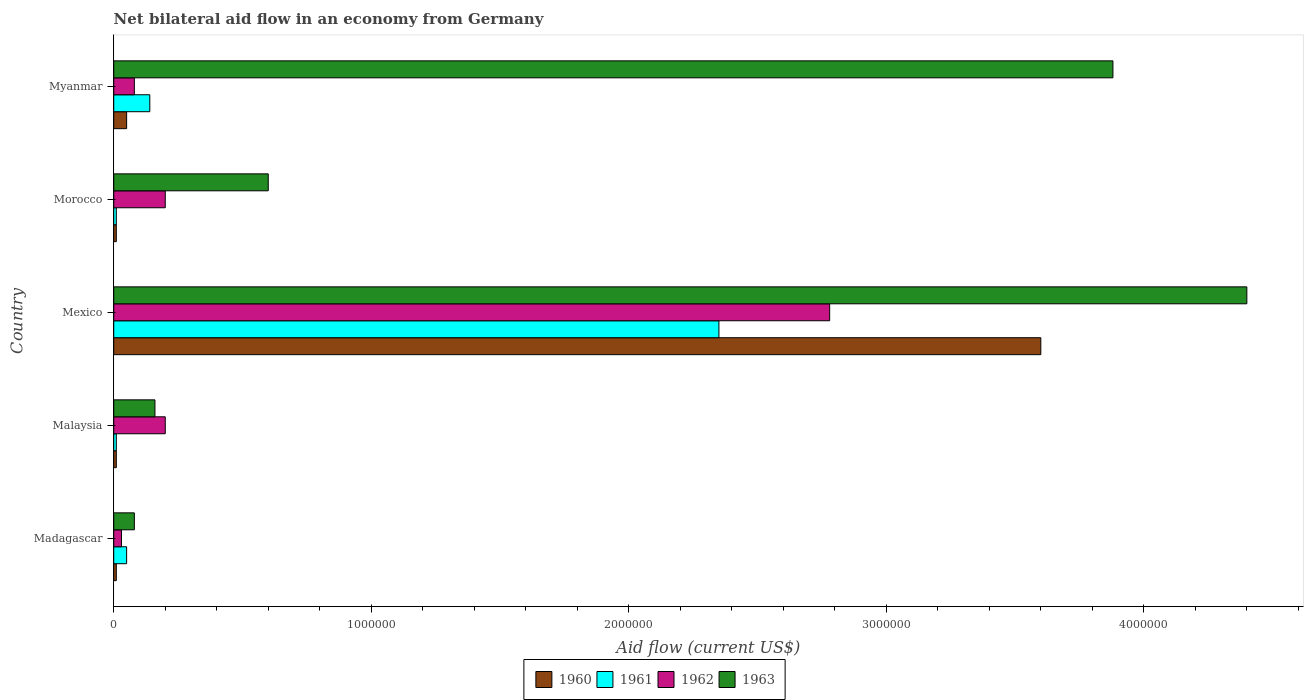How many different coloured bars are there?
Offer a very short reply. 4. Are the number of bars on each tick of the Y-axis equal?
Offer a terse response. Yes. What is the label of the 3rd group of bars from the top?
Your answer should be very brief. Mexico. What is the net bilateral aid flow in 1963 in Malaysia?
Ensure brevity in your answer.  1.60e+05. Across all countries, what is the maximum net bilateral aid flow in 1962?
Your response must be concise. 2.78e+06. Across all countries, what is the minimum net bilateral aid flow in 1962?
Give a very brief answer. 3.00e+04. In which country was the net bilateral aid flow in 1963 minimum?
Keep it short and to the point. Madagascar. What is the total net bilateral aid flow in 1963 in the graph?
Provide a short and direct response. 9.12e+06. What is the difference between the net bilateral aid flow in 1963 in Malaysia and that in Mexico?
Your response must be concise. -4.24e+06. What is the difference between the net bilateral aid flow in 1963 in Morocco and the net bilateral aid flow in 1962 in Mexico?
Keep it short and to the point. -2.18e+06. What is the average net bilateral aid flow in 1961 per country?
Your response must be concise. 5.12e+05. What is the difference between the highest and the second highest net bilateral aid flow in 1961?
Give a very brief answer. 2.21e+06. What is the difference between the highest and the lowest net bilateral aid flow in 1963?
Your answer should be very brief. 4.32e+06. What does the 3rd bar from the top in Malaysia represents?
Offer a very short reply. 1961. What does the 2nd bar from the bottom in Madagascar represents?
Offer a terse response. 1961. How many bars are there?
Offer a very short reply. 20. Are all the bars in the graph horizontal?
Offer a very short reply. Yes. Are the values on the major ticks of X-axis written in scientific E-notation?
Keep it short and to the point. No. Does the graph contain any zero values?
Provide a short and direct response. No. Does the graph contain grids?
Your answer should be compact. No. Where does the legend appear in the graph?
Ensure brevity in your answer.  Bottom center. How many legend labels are there?
Offer a very short reply. 4. How are the legend labels stacked?
Offer a terse response. Horizontal. What is the title of the graph?
Offer a terse response. Net bilateral aid flow in an economy from Germany. Does "2005" appear as one of the legend labels in the graph?
Provide a short and direct response. No. What is the label or title of the X-axis?
Offer a terse response. Aid flow (current US$). What is the label or title of the Y-axis?
Your response must be concise. Country. What is the Aid flow (current US$) in 1961 in Madagascar?
Your response must be concise. 5.00e+04. What is the Aid flow (current US$) in 1962 in Madagascar?
Your answer should be compact. 3.00e+04. What is the Aid flow (current US$) of 1961 in Malaysia?
Offer a terse response. 10000. What is the Aid flow (current US$) in 1960 in Mexico?
Provide a succinct answer. 3.60e+06. What is the Aid flow (current US$) of 1961 in Mexico?
Your response must be concise. 2.35e+06. What is the Aid flow (current US$) of 1962 in Mexico?
Give a very brief answer. 2.78e+06. What is the Aid flow (current US$) of 1963 in Mexico?
Keep it short and to the point. 4.40e+06. What is the Aid flow (current US$) in 1960 in Morocco?
Give a very brief answer. 10000. What is the Aid flow (current US$) in 1963 in Morocco?
Provide a succinct answer. 6.00e+05. What is the Aid flow (current US$) in 1960 in Myanmar?
Offer a terse response. 5.00e+04. What is the Aid flow (current US$) in 1962 in Myanmar?
Your answer should be compact. 8.00e+04. What is the Aid flow (current US$) of 1963 in Myanmar?
Provide a short and direct response. 3.88e+06. Across all countries, what is the maximum Aid flow (current US$) in 1960?
Give a very brief answer. 3.60e+06. Across all countries, what is the maximum Aid flow (current US$) of 1961?
Offer a terse response. 2.35e+06. Across all countries, what is the maximum Aid flow (current US$) of 1962?
Offer a very short reply. 2.78e+06. Across all countries, what is the maximum Aid flow (current US$) in 1963?
Your answer should be very brief. 4.40e+06. Across all countries, what is the minimum Aid flow (current US$) in 1960?
Your answer should be very brief. 10000. What is the total Aid flow (current US$) of 1960 in the graph?
Provide a short and direct response. 3.68e+06. What is the total Aid flow (current US$) in 1961 in the graph?
Provide a short and direct response. 2.56e+06. What is the total Aid flow (current US$) of 1962 in the graph?
Offer a very short reply. 3.29e+06. What is the total Aid flow (current US$) of 1963 in the graph?
Give a very brief answer. 9.12e+06. What is the difference between the Aid flow (current US$) in 1960 in Madagascar and that in Mexico?
Provide a succinct answer. -3.59e+06. What is the difference between the Aid flow (current US$) in 1961 in Madagascar and that in Mexico?
Keep it short and to the point. -2.30e+06. What is the difference between the Aid flow (current US$) of 1962 in Madagascar and that in Mexico?
Your answer should be very brief. -2.75e+06. What is the difference between the Aid flow (current US$) in 1963 in Madagascar and that in Mexico?
Offer a very short reply. -4.32e+06. What is the difference between the Aid flow (current US$) in 1961 in Madagascar and that in Morocco?
Make the answer very short. 4.00e+04. What is the difference between the Aid flow (current US$) in 1962 in Madagascar and that in Morocco?
Your response must be concise. -1.70e+05. What is the difference between the Aid flow (current US$) in 1963 in Madagascar and that in Morocco?
Ensure brevity in your answer.  -5.20e+05. What is the difference between the Aid flow (current US$) of 1963 in Madagascar and that in Myanmar?
Ensure brevity in your answer.  -3.80e+06. What is the difference between the Aid flow (current US$) in 1960 in Malaysia and that in Mexico?
Your response must be concise. -3.59e+06. What is the difference between the Aid flow (current US$) of 1961 in Malaysia and that in Mexico?
Offer a terse response. -2.34e+06. What is the difference between the Aid flow (current US$) of 1962 in Malaysia and that in Mexico?
Your response must be concise. -2.58e+06. What is the difference between the Aid flow (current US$) in 1963 in Malaysia and that in Mexico?
Your answer should be very brief. -4.24e+06. What is the difference between the Aid flow (current US$) of 1960 in Malaysia and that in Morocco?
Your answer should be compact. 0. What is the difference between the Aid flow (current US$) in 1961 in Malaysia and that in Morocco?
Your answer should be very brief. 0. What is the difference between the Aid flow (current US$) in 1962 in Malaysia and that in Morocco?
Provide a short and direct response. 0. What is the difference between the Aid flow (current US$) of 1963 in Malaysia and that in Morocco?
Your response must be concise. -4.40e+05. What is the difference between the Aid flow (current US$) of 1963 in Malaysia and that in Myanmar?
Offer a very short reply. -3.72e+06. What is the difference between the Aid flow (current US$) of 1960 in Mexico and that in Morocco?
Provide a short and direct response. 3.59e+06. What is the difference between the Aid flow (current US$) in 1961 in Mexico and that in Morocco?
Offer a terse response. 2.34e+06. What is the difference between the Aid flow (current US$) of 1962 in Mexico and that in Morocco?
Give a very brief answer. 2.58e+06. What is the difference between the Aid flow (current US$) in 1963 in Mexico and that in Morocco?
Your answer should be very brief. 3.80e+06. What is the difference between the Aid flow (current US$) in 1960 in Mexico and that in Myanmar?
Provide a short and direct response. 3.55e+06. What is the difference between the Aid flow (current US$) of 1961 in Mexico and that in Myanmar?
Give a very brief answer. 2.21e+06. What is the difference between the Aid flow (current US$) of 1962 in Mexico and that in Myanmar?
Keep it short and to the point. 2.70e+06. What is the difference between the Aid flow (current US$) in 1963 in Mexico and that in Myanmar?
Keep it short and to the point. 5.20e+05. What is the difference between the Aid flow (current US$) of 1961 in Morocco and that in Myanmar?
Your response must be concise. -1.30e+05. What is the difference between the Aid flow (current US$) of 1963 in Morocco and that in Myanmar?
Give a very brief answer. -3.28e+06. What is the difference between the Aid flow (current US$) in 1960 in Madagascar and the Aid flow (current US$) in 1963 in Malaysia?
Offer a terse response. -1.50e+05. What is the difference between the Aid flow (current US$) in 1961 in Madagascar and the Aid flow (current US$) in 1962 in Malaysia?
Ensure brevity in your answer.  -1.50e+05. What is the difference between the Aid flow (current US$) of 1960 in Madagascar and the Aid flow (current US$) of 1961 in Mexico?
Keep it short and to the point. -2.34e+06. What is the difference between the Aid flow (current US$) of 1960 in Madagascar and the Aid flow (current US$) of 1962 in Mexico?
Provide a short and direct response. -2.77e+06. What is the difference between the Aid flow (current US$) in 1960 in Madagascar and the Aid flow (current US$) in 1963 in Mexico?
Offer a terse response. -4.39e+06. What is the difference between the Aid flow (current US$) of 1961 in Madagascar and the Aid flow (current US$) of 1962 in Mexico?
Keep it short and to the point. -2.73e+06. What is the difference between the Aid flow (current US$) of 1961 in Madagascar and the Aid flow (current US$) of 1963 in Mexico?
Make the answer very short. -4.35e+06. What is the difference between the Aid flow (current US$) of 1962 in Madagascar and the Aid flow (current US$) of 1963 in Mexico?
Your answer should be compact. -4.37e+06. What is the difference between the Aid flow (current US$) of 1960 in Madagascar and the Aid flow (current US$) of 1962 in Morocco?
Give a very brief answer. -1.90e+05. What is the difference between the Aid flow (current US$) in 1960 in Madagascar and the Aid flow (current US$) in 1963 in Morocco?
Offer a terse response. -5.90e+05. What is the difference between the Aid flow (current US$) in 1961 in Madagascar and the Aid flow (current US$) in 1963 in Morocco?
Offer a terse response. -5.50e+05. What is the difference between the Aid flow (current US$) in 1962 in Madagascar and the Aid flow (current US$) in 1963 in Morocco?
Your answer should be compact. -5.70e+05. What is the difference between the Aid flow (current US$) in 1960 in Madagascar and the Aid flow (current US$) in 1963 in Myanmar?
Ensure brevity in your answer.  -3.87e+06. What is the difference between the Aid flow (current US$) of 1961 in Madagascar and the Aid flow (current US$) of 1962 in Myanmar?
Keep it short and to the point. -3.00e+04. What is the difference between the Aid flow (current US$) in 1961 in Madagascar and the Aid flow (current US$) in 1963 in Myanmar?
Your response must be concise. -3.83e+06. What is the difference between the Aid flow (current US$) in 1962 in Madagascar and the Aid flow (current US$) in 1963 in Myanmar?
Provide a succinct answer. -3.85e+06. What is the difference between the Aid flow (current US$) in 1960 in Malaysia and the Aid flow (current US$) in 1961 in Mexico?
Provide a short and direct response. -2.34e+06. What is the difference between the Aid flow (current US$) in 1960 in Malaysia and the Aid flow (current US$) in 1962 in Mexico?
Keep it short and to the point. -2.77e+06. What is the difference between the Aid flow (current US$) of 1960 in Malaysia and the Aid flow (current US$) of 1963 in Mexico?
Your response must be concise. -4.39e+06. What is the difference between the Aid flow (current US$) in 1961 in Malaysia and the Aid flow (current US$) in 1962 in Mexico?
Your response must be concise. -2.77e+06. What is the difference between the Aid flow (current US$) in 1961 in Malaysia and the Aid flow (current US$) in 1963 in Mexico?
Offer a very short reply. -4.39e+06. What is the difference between the Aid flow (current US$) in 1962 in Malaysia and the Aid flow (current US$) in 1963 in Mexico?
Keep it short and to the point. -4.20e+06. What is the difference between the Aid flow (current US$) in 1960 in Malaysia and the Aid flow (current US$) in 1963 in Morocco?
Your response must be concise. -5.90e+05. What is the difference between the Aid flow (current US$) in 1961 in Malaysia and the Aid flow (current US$) in 1963 in Morocco?
Your answer should be compact. -5.90e+05. What is the difference between the Aid flow (current US$) of 1962 in Malaysia and the Aid flow (current US$) of 1963 in Morocco?
Your response must be concise. -4.00e+05. What is the difference between the Aid flow (current US$) in 1960 in Malaysia and the Aid flow (current US$) in 1963 in Myanmar?
Ensure brevity in your answer.  -3.87e+06. What is the difference between the Aid flow (current US$) in 1961 in Malaysia and the Aid flow (current US$) in 1962 in Myanmar?
Offer a terse response. -7.00e+04. What is the difference between the Aid flow (current US$) in 1961 in Malaysia and the Aid flow (current US$) in 1963 in Myanmar?
Your answer should be very brief. -3.87e+06. What is the difference between the Aid flow (current US$) in 1962 in Malaysia and the Aid flow (current US$) in 1963 in Myanmar?
Ensure brevity in your answer.  -3.68e+06. What is the difference between the Aid flow (current US$) in 1960 in Mexico and the Aid flow (current US$) in 1961 in Morocco?
Your response must be concise. 3.59e+06. What is the difference between the Aid flow (current US$) of 1960 in Mexico and the Aid flow (current US$) of 1962 in Morocco?
Your answer should be very brief. 3.40e+06. What is the difference between the Aid flow (current US$) in 1961 in Mexico and the Aid flow (current US$) in 1962 in Morocco?
Keep it short and to the point. 2.15e+06. What is the difference between the Aid flow (current US$) in 1961 in Mexico and the Aid flow (current US$) in 1963 in Morocco?
Your answer should be compact. 1.75e+06. What is the difference between the Aid flow (current US$) of 1962 in Mexico and the Aid flow (current US$) of 1963 in Morocco?
Ensure brevity in your answer.  2.18e+06. What is the difference between the Aid flow (current US$) in 1960 in Mexico and the Aid flow (current US$) in 1961 in Myanmar?
Give a very brief answer. 3.46e+06. What is the difference between the Aid flow (current US$) of 1960 in Mexico and the Aid flow (current US$) of 1962 in Myanmar?
Ensure brevity in your answer.  3.52e+06. What is the difference between the Aid flow (current US$) in 1960 in Mexico and the Aid flow (current US$) in 1963 in Myanmar?
Offer a terse response. -2.80e+05. What is the difference between the Aid flow (current US$) in 1961 in Mexico and the Aid flow (current US$) in 1962 in Myanmar?
Your answer should be compact. 2.27e+06. What is the difference between the Aid flow (current US$) of 1961 in Mexico and the Aid flow (current US$) of 1963 in Myanmar?
Your answer should be compact. -1.53e+06. What is the difference between the Aid flow (current US$) in 1962 in Mexico and the Aid flow (current US$) in 1963 in Myanmar?
Make the answer very short. -1.10e+06. What is the difference between the Aid flow (current US$) of 1960 in Morocco and the Aid flow (current US$) of 1963 in Myanmar?
Your answer should be compact. -3.87e+06. What is the difference between the Aid flow (current US$) of 1961 in Morocco and the Aid flow (current US$) of 1963 in Myanmar?
Provide a succinct answer. -3.87e+06. What is the difference between the Aid flow (current US$) of 1962 in Morocco and the Aid flow (current US$) of 1963 in Myanmar?
Your response must be concise. -3.68e+06. What is the average Aid flow (current US$) in 1960 per country?
Your answer should be compact. 7.36e+05. What is the average Aid flow (current US$) of 1961 per country?
Ensure brevity in your answer.  5.12e+05. What is the average Aid flow (current US$) in 1962 per country?
Ensure brevity in your answer.  6.58e+05. What is the average Aid flow (current US$) of 1963 per country?
Provide a short and direct response. 1.82e+06. What is the difference between the Aid flow (current US$) in 1960 and Aid flow (current US$) in 1962 in Madagascar?
Your answer should be very brief. -2.00e+04. What is the difference between the Aid flow (current US$) of 1960 and Aid flow (current US$) of 1963 in Madagascar?
Your answer should be compact. -7.00e+04. What is the difference between the Aid flow (current US$) in 1960 and Aid flow (current US$) in 1962 in Malaysia?
Provide a short and direct response. -1.90e+05. What is the difference between the Aid flow (current US$) of 1960 and Aid flow (current US$) of 1963 in Malaysia?
Your response must be concise. -1.50e+05. What is the difference between the Aid flow (current US$) in 1961 and Aid flow (current US$) in 1963 in Malaysia?
Give a very brief answer. -1.50e+05. What is the difference between the Aid flow (current US$) in 1960 and Aid flow (current US$) in 1961 in Mexico?
Your response must be concise. 1.25e+06. What is the difference between the Aid flow (current US$) of 1960 and Aid flow (current US$) of 1962 in Mexico?
Make the answer very short. 8.20e+05. What is the difference between the Aid flow (current US$) of 1960 and Aid flow (current US$) of 1963 in Mexico?
Make the answer very short. -8.00e+05. What is the difference between the Aid flow (current US$) in 1961 and Aid flow (current US$) in 1962 in Mexico?
Offer a terse response. -4.30e+05. What is the difference between the Aid flow (current US$) of 1961 and Aid flow (current US$) of 1963 in Mexico?
Provide a succinct answer. -2.05e+06. What is the difference between the Aid flow (current US$) in 1962 and Aid flow (current US$) in 1963 in Mexico?
Ensure brevity in your answer.  -1.62e+06. What is the difference between the Aid flow (current US$) in 1960 and Aid flow (current US$) in 1961 in Morocco?
Give a very brief answer. 0. What is the difference between the Aid flow (current US$) in 1960 and Aid flow (current US$) in 1963 in Morocco?
Your answer should be very brief. -5.90e+05. What is the difference between the Aid flow (current US$) in 1961 and Aid flow (current US$) in 1962 in Morocco?
Keep it short and to the point. -1.90e+05. What is the difference between the Aid flow (current US$) in 1961 and Aid flow (current US$) in 1963 in Morocco?
Your response must be concise. -5.90e+05. What is the difference between the Aid flow (current US$) in 1962 and Aid flow (current US$) in 1963 in Morocco?
Ensure brevity in your answer.  -4.00e+05. What is the difference between the Aid flow (current US$) in 1960 and Aid flow (current US$) in 1963 in Myanmar?
Your response must be concise. -3.83e+06. What is the difference between the Aid flow (current US$) in 1961 and Aid flow (current US$) in 1962 in Myanmar?
Keep it short and to the point. 6.00e+04. What is the difference between the Aid flow (current US$) of 1961 and Aid flow (current US$) of 1963 in Myanmar?
Keep it short and to the point. -3.74e+06. What is the difference between the Aid flow (current US$) in 1962 and Aid flow (current US$) in 1963 in Myanmar?
Your answer should be very brief. -3.80e+06. What is the ratio of the Aid flow (current US$) in 1961 in Madagascar to that in Malaysia?
Ensure brevity in your answer.  5. What is the ratio of the Aid flow (current US$) of 1962 in Madagascar to that in Malaysia?
Provide a short and direct response. 0.15. What is the ratio of the Aid flow (current US$) of 1963 in Madagascar to that in Malaysia?
Provide a succinct answer. 0.5. What is the ratio of the Aid flow (current US$) in 1960 in Madagascar to that in Mexico?
Offer a terse response. 0. What is the ratio of the Aid flow (current US$) in 1961 in Madagascar to that in Mexico?
Your answer should be compact. 0.02. What is the ratio of the Aid flow (current US$) in 1962 in Madagascar to that in Mexico?
Offer a very short reply. 0.01. What is the ratio of the Aid flow (current US$) of 1963 in Madagascar to that in Mexico?
Your answer should be very brief. 0.02. What is the ratio of the Aid flow (current US$) of 1960 in Madagascar to that in Morocco?
Provide a succinct answer. 1. What is the ratio of the Aid flow (current US$) of 1961 in Madagascar to that in Morocco?
Your answer should be compact. 5. What is the ratio of the Aid flow (current US$) in 1962 in Madagascar to that in Morocco?
Provide a succinct answer. 0.15. What is the ratio of the Aid flow (current US$) in 1963 in Madagascar to that in Morocco?
Offer a very short reply. 0.13. What is the ratio of the Aid flow (current US$) in 1961 in Madagascar to that in Myanmar?
Provide a succinct answer. 0.36. What is the ratio of the Aid flow (current US$) in 1963 in Madagascar to that in Myanmar?
Your answer should be compact. 0.02. What is the ratio of the Aid flow (current US$) of 1960 in Malaysia to that in Mexico?
Offer a very short reply. 0. What is the ratio of the Aid flow (current US$) in 1961 in Malaysia to that in Mexico?
Give a very brief answer. 0. What is the ratio of the Aid flow (current US$) of 1962 in Malaysia to that in Mexico?
Give a very brief answer. 0.07. What is the ratio of the Aid flow (current US$) in 1963 in Malaysia to that in Mexico?
Your answer should be compact. 0.04. What is the ratio of the Aid flow (current US$) in 1960 in Malaysia to that in Morocco?
Give a very brief answer. 1. What is the ratio of the Aid flow (current US$) of 1962 in Malaysia to that in Morocco?
Provide a succinct answer. 1. What is the ratio of the Aid flow (current US$) of 1963 in Malaysia to that in Morocco?
Ensure brevity in your answer.  0.27. What is the ratio of the Aid flow (current US$) in 1961 in Malaysia to that in Myanmar?
Offer a very short reply. 0.07. What is the ratio of the Aid flow (current US$) in 1962 in Malaysia to that in Myanmar?
Keep it short and to the point. 2.5. What is the ratio of the Aid flow (current US$) of 1963 in Malaysia to that in Myanmar?
Provide a short and direct response. 0.04. What is the ratio of the Aid flow (current US$) in 1960 in Mexico to that in Morocco?
Ensure brevity in your answer.  360. What is the ratio of the Aid flow (current US$) of 1961 in Mexico to that in Morocco?
Provide a short and direct response. 235. What is the ratio of the Aid flow (current US$) of 1962 in Mexico to that in Morocco?
Ensure brevity in your answer.  13.9. What is the ratio of the Aid flow (current US$) of 1963 in Mexico to that in Morocco?
Provide a succinct answer. 7.33. What is the ratio of the Aid flow (current US$) of 1961 in Mexico to that in Myanmar?
Make the answer very short. 16.79. What is the ratio of the Aid flow (current US$) in 1962 in Mexico to that in Myanmar?
Offer a terse response. 34.75. What is the ratio of the Aid flow (current US$) in 1963 in Mexico to that in Myanmar?
Your answer should be very brief. 1.13. What is the ratio of the Aid flow (current US$) of 1961 in Morocco to that in Myanmar?
Your answer should be compact. 0.07. What is the ratio of the Aid flow (current US$) in 1963 in Morocco to that in Myanmar?
Provide a short and direct response. 0.15. What is the difference between the highest and the second highest Aid flow (current US$) of 1960?
Give a very brief answer. 3.55e+06. What is the difference between the highest and the second highest Aid flow (current US$) of 1961?
Your response must be concise. 2.21e+06. What is the difference between the highest and the second highest Aid flow (current US$) of 1962?
Make the answer very short. 2.58e+06. What is the difference between the highest and the second highest Aid flow (current US$) in 1963?
Your answer should be compact. 5.20e+05. What is the difference between the highest and the lowest Aid flow (current US$) in 1960?
Make the answer very short. 3.59e+06. What is the difference between the highest and the lowest Aid flow (current US$) of 1961?
Keep it short and to the point. 2.34e+06. What is the difference between the highest and the lowest Aid flow (current US$) in 1962?
Offer a very short reply. 2.75e+06. What is the difference between the highest and the lowest Aid flow (current US$) in 1963?
Provide a short and direct response. 4.32e+06. 